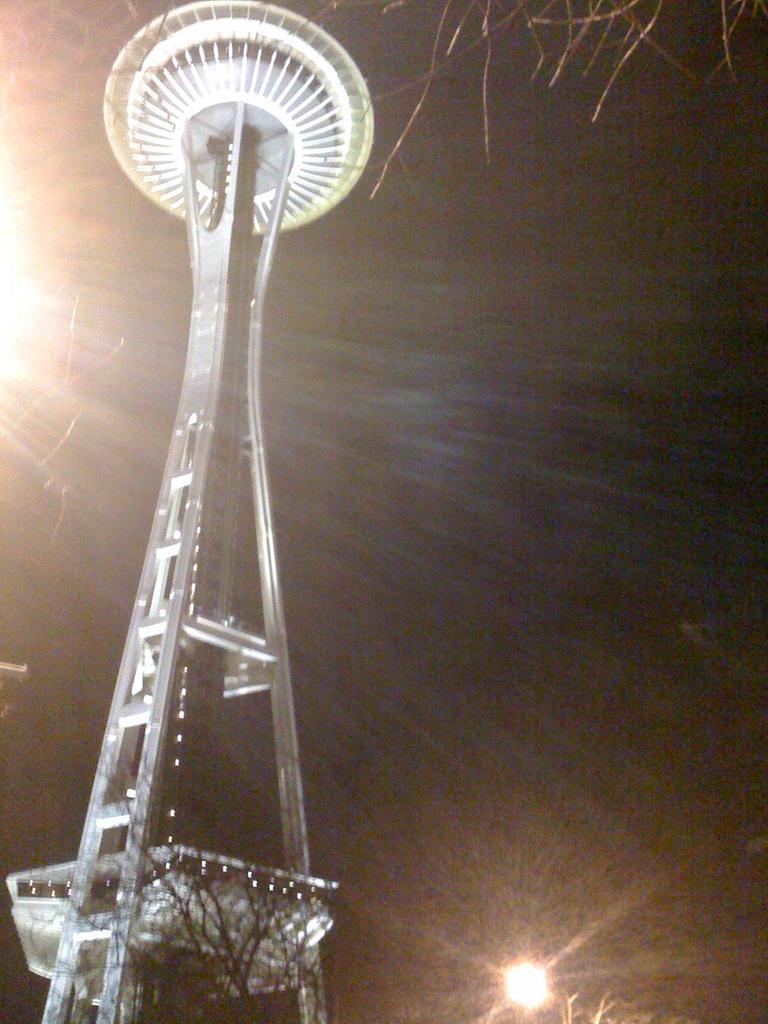How would you summarize this image in a sentence or two? In this picture we can see a tower here, there are two lights here, we can see dark background. 